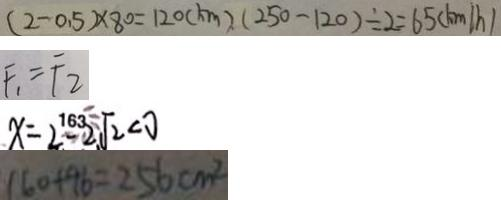Convert formula to latex. <formula><loc_0><loc_0><loc_500><loc_500>( 2 - 0 . 5 ) \times 8 0 = 1 2 0 ( k m ) ( 2 5 0 - 1 2 0 ) \div 2 = 6 5 ( k m / h ) 
 F _ { 1 } = F _ { 2 } 
 x = 2 - 2 \sqrt { 2 } < 0 
 1 6 0 + 9 6 = 2 5 6 c m ^ { 2 }</formula> 